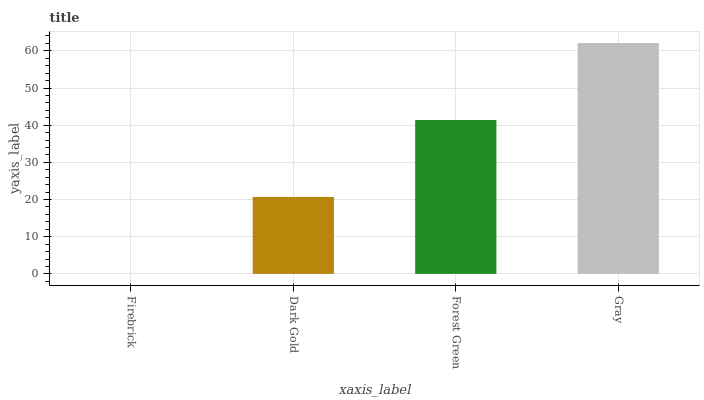Is Dark Gold the minimum?
Answer yes or no. No. Is Dark Gold the maximum?
Answer yes or no. No. Is Dark Gold greater than Firebrick?
Answer yes or no. Yes. Is Firebrick less than Dark Gold?
Answer yes or no. Yes. Is Firebrick greater than Dark Gold?
Answer yes or no. No. Is Dark Gold less than Firebrick?
Answer yes or no. No. Is Forest Green the high median?
Answer yes or no. Yes. Is Dark Gold the low median?
Answer yes or no. Yes. Is Gray the high median?
Answer yes or no. No. Is Forest Green the low median?
Answer yes or no. No. 